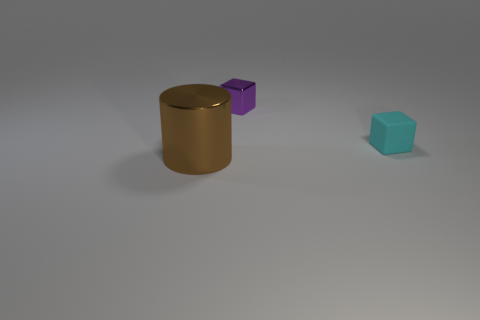Add 3 gray cylinders. How many objects exist? 6 Subtract all blocks. How many objects are left? 1 Subtract 0 yellow cylinders. How many objects are left? 3 Subtract all small cyan things. Subtract all cyan blocks. How many objects are left? 1 Add 3 small cyan cubes. How many small cyan cubes are left? 4 Add 3 cyan objects. How many cyan objects exist? 4 